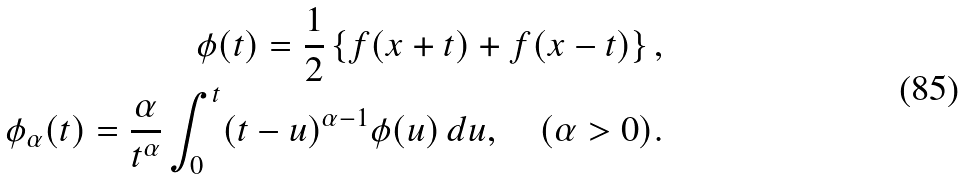Convert formula to latex. <formula><loc_0><loc_0><loc_500><loc_500>\phi ( t ) = \frac { 1 } { 2 } \left \{ f ( x + t ) + f ( x - t ) \right \} , \\ \phi _ { \alpha } ( t ) = \frac { \alpha } { t ^ { \alpha } } \int _ { 0 } ^ { t } ( t - u ) ^ { \alpha - 1 } \phi ( u ) \, d u , \quad ( \alpha > 0 ) .</formula> 